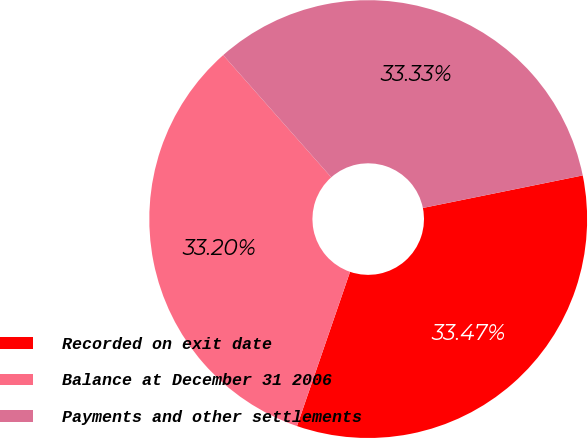Convert chart. <chart><loc_0><loc_0><loc_500><loc_500><pie_chart><fcel>Recorded on exit date<fcel>Balance at December 31 2006<fcel>Payments and other settlements<nl><fcel>33.47%<fcel>33.2%<fcel>33.33%<nl></chart> 